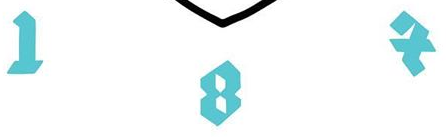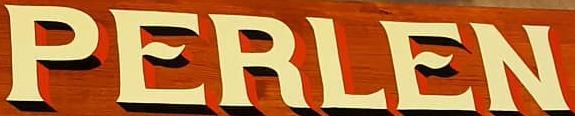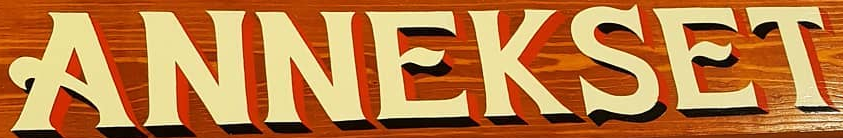Transcribe the words shown in these images in order, separated by a semicolon. IBX; PERLEN; ANNEKSET 